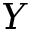<formula> <loc_0><loc_0><loc_500><loc_500>Y</formula> 